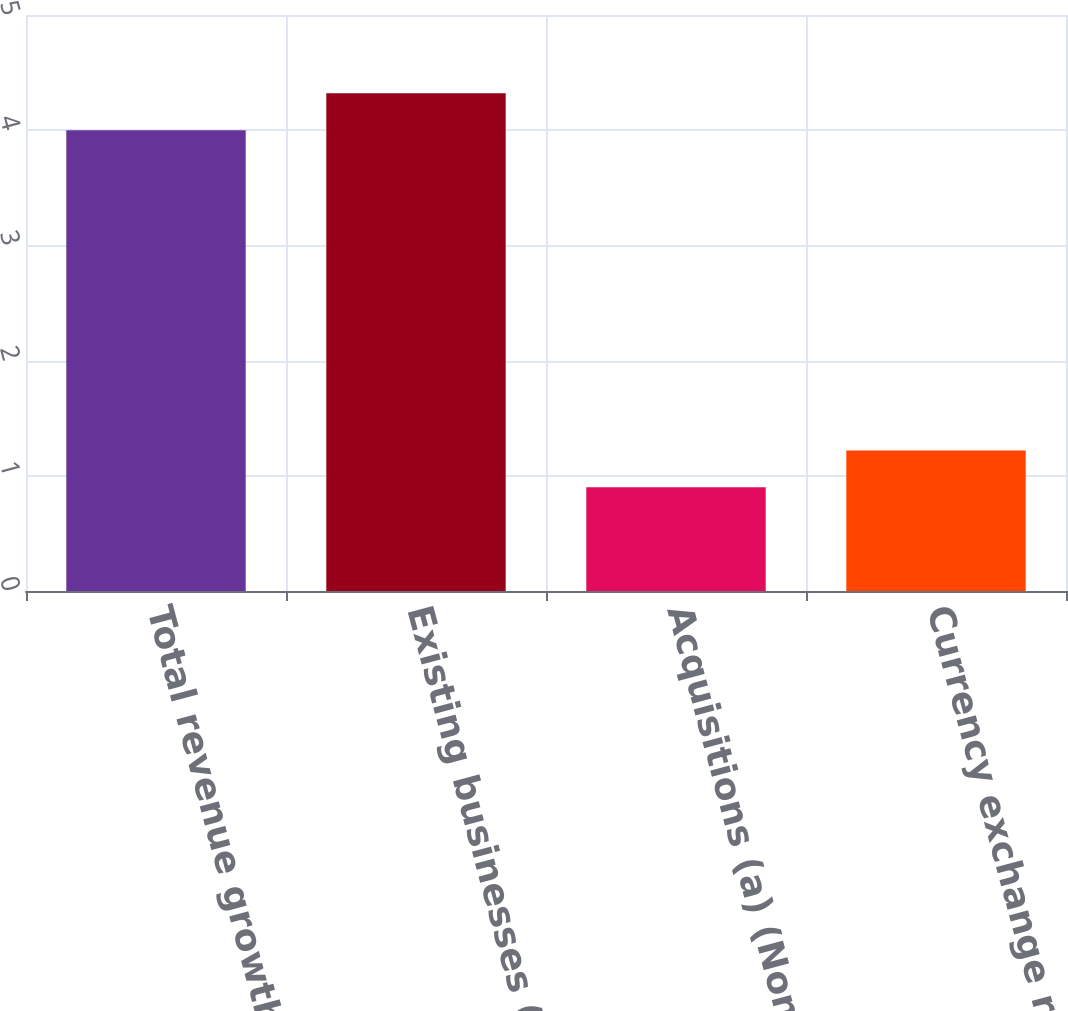Convert chart. <chart><loc_0><loc_0><loc_500><loc_500><bar_chart><fcel>Total revenue growth (GAAP)<fcel>Existing businesses (Non -<fcel>Acquisitions (a) (Non - GAAP)<fcel>Currency exchange rates (Non -<nl><fcel>4<fcel>4.32<fcel>0.9<fcel>1.22<nl></chart> 